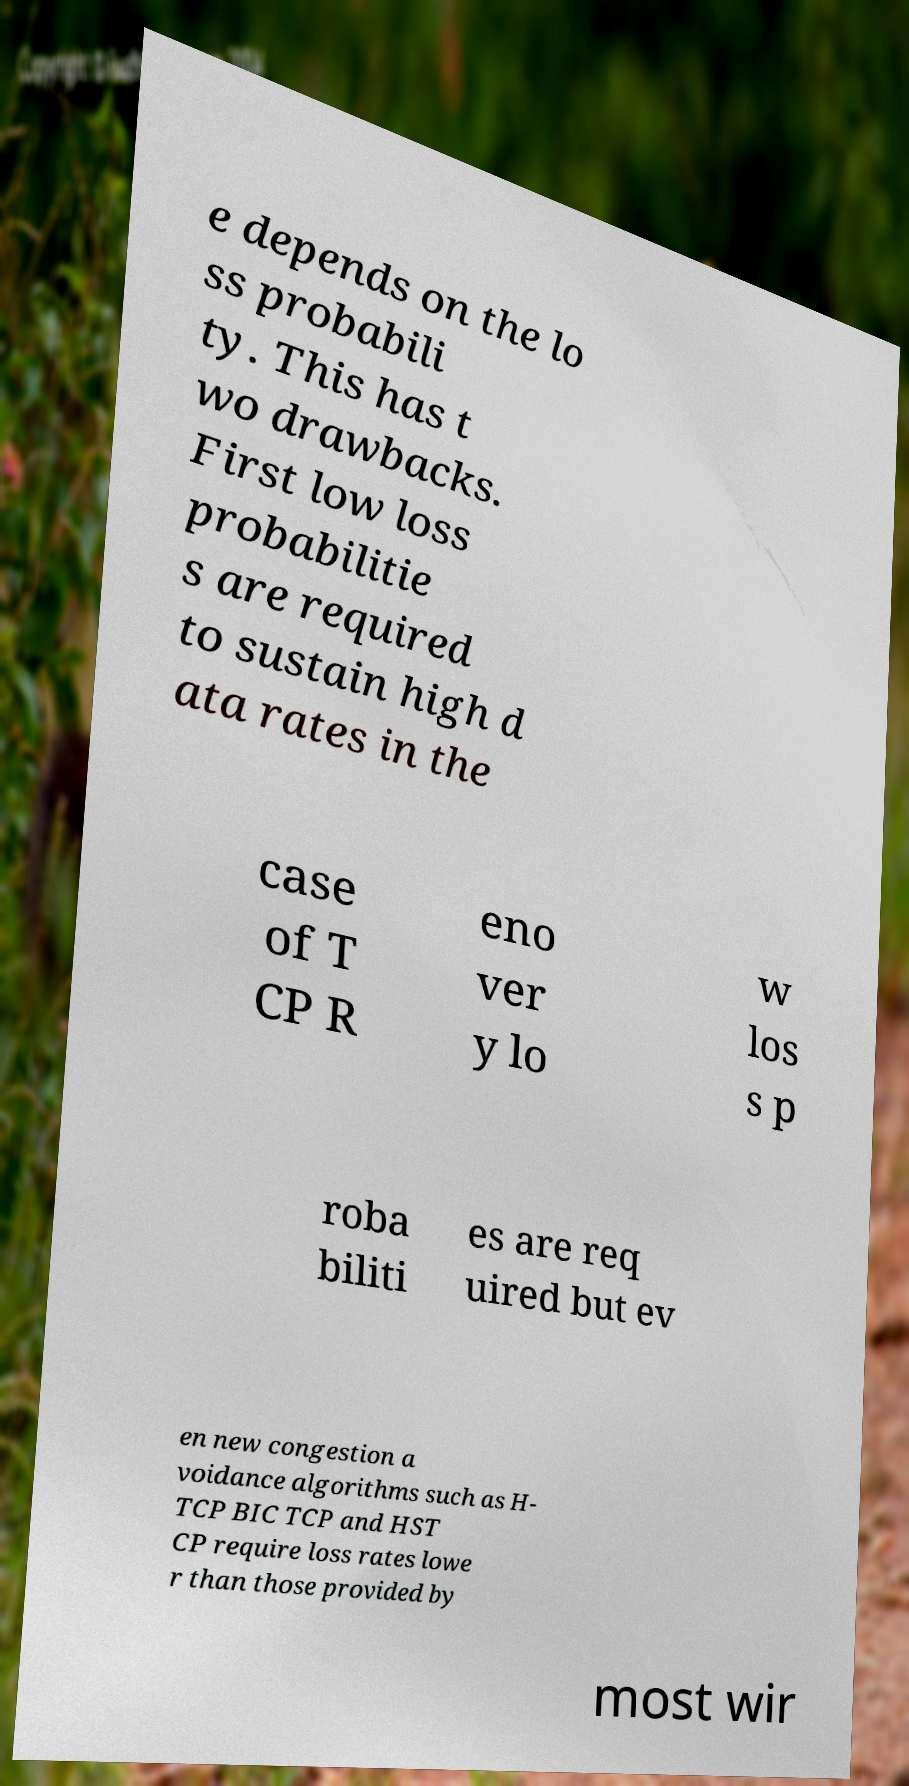Could you extract and type out the text from this image? e depends on the lo ss probabili ty. This has t wo drawbacks. First low loss probabilitie s are required to sustain high d ata rates in the case of T CP R eno ver y lo w los s p roba biliti es are req uired but ev en new congestion a voidance algorithms such as H- TCP BIC TCP and HST CP require loss rates lowe r than those provided by most wir 